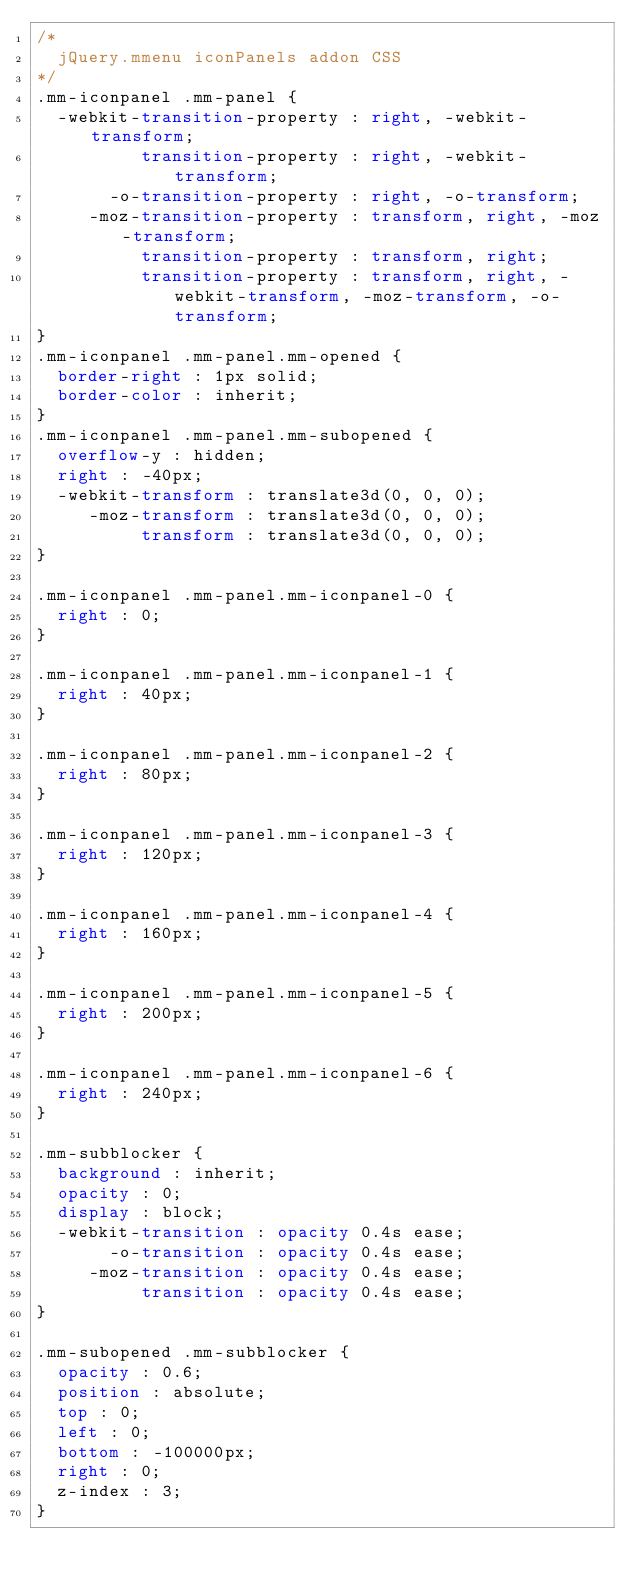Convert code to text. <code><loc_0><loc_0><loc_500><loc_500><_CSS_>/*
	jQuery.mmenu iconPanels addon CSS
*/
.mm-iconpanel .mm-panel {
  -webkit-transition-property : right, -webkit-transform;
          transition-property : right, -webkit-transform;
       -o-transition-property : right, -o-transform;
     -moz-transition-property : transform, right, -moz-transform;
          transition-property : transform, right;
          transition-property : transform, right, -webkit-transform, -moz-transform, -o-transform;
}
.mm-iconpanel .mm-panel.mm-opened {
  border-right : 1px solid;
  border-color : inherit;
}
.mm-iconpanel .mm-panel.mm-subopened {
  overflow-y : hidden;
  right : -40px;
  -webkit-transform : translate3d(0, 0, 0);
     -moz-transform : translate3d(0, 0, 0);
          transform : translate3d(0, 0, 0);
}

.mm-iconpanel .mm-panel.mm-iconpanel-0 {
  right : 0;
}

.mm-iconpanel .mm-panel.mm-iconpanel-1 {
  right : 40px;
}

.mm-iconpanel .mm-panel.mm-iconpanel-2 {
  right : 80px;
}

.mm-iconpanel .mm-panel.mm-iconpanel-3 {
  right : 120px;
}

.mm-iconpanel .mm-panel.mm-iconpanel-4 {
  right : 160px;
}

.mm-iconpanel .mm-panel.mm-iconpanel-5 {
  right : 200px;
}

.mm-iconpanel .mm-panel.mm-iconpanel-6 {
  right : 240px;
}

.mm-subblocker {
  background : inherit;
  opacity : 0;
  display : block;
  -webkit-transition : opacity 0.4s ease;
       -o-transition : opacity 0.4s ease;
     -moz-transition : opacity 0.4s ease;
          transition : opacity 0.4s ease;
}

.mm-subopened .mm-subblocker {
  opacity : 0.6;
  position : absolute;
  top : 0;
  left : 0;
  bottom : -100000px;
  right : 0;
  z-index : 3;
}</code> 